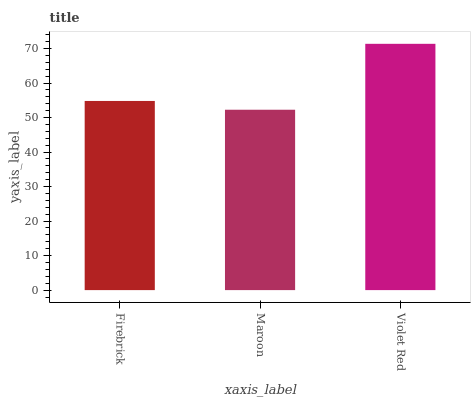Is Maroon the minimum?
Answer yes or no. Yes. Is Violet Red the maximum?
Answer yes or no. Yes. Is Violet Red the minimum?
Answer yes or no. No. Is Maroon the maximum?
Answer yes or no. No. Is Violet Red greater than Maroon?
Answer yes or no. Yes. Is Maroon less than Violet Red?
Answer yes or no. Yes. Is Maroon greater than Violet Red?
Answer yes or no. No. Is Violet Red less than Maroon?
Answer yes or no. No. Is Firebrick the high median?
Answer yes or no. Yes. Is Firebrick the low median?
Answer yes or no. Yes. Is Violet Red the high median?
Answer yes or no. No. Is Violet Red the low median?
Answer yes or no. No. 